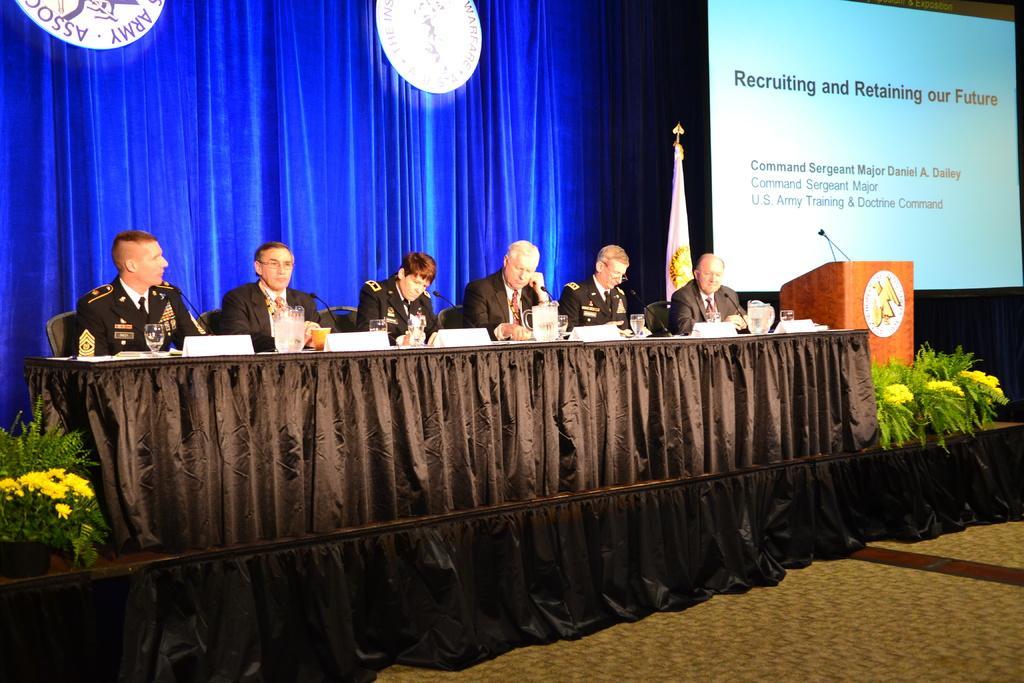Describe this image in one or two sentences. A group of men are sitting on the chairs, they wore coats, ties, shirts. Behind them there is a blue color curtain. On the right side there is a podium and a projector screen. 